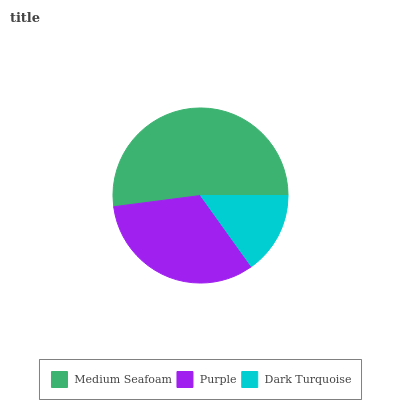Is Dark Turquoise the minimum?
Answer yes or no. Yes. Is Medium Seafoam the maximum?
Answer yes or no. Yes. Is Purple the minimum?
Answer yes or no. No. Is Purple the maximum?
Answer yes or no. No. Is Medium Seafoam greater than Purple?
Answer yes or no. Yes. Is Purple less than Medium Seafoam?
Answer yes or no. Yes. Is Purple greater than Medium Seafoam?
Answer yes or no. No. Is Medium Seafoam less than Purple?
Answer yes or no. No. Is Purple the high median?
Answer yes or no. Yes. Is Purple the low median?
Answer yes or no. Yes. Is Medium Seafoam the high median?
Answer yes or no. No. Is Medium Seafoam the low median?
Answer yes or no. No. 